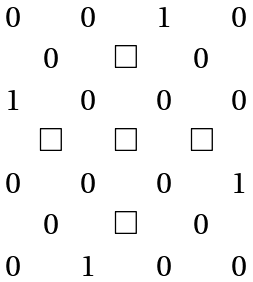Convert formula to latex. <formula><loc_0><loc_0><loc_500><loc_500>\begin{array} { c c c c c c c } 0 & & 0 & & 1 & & 0 \\ & 0 & & \Box & & 0 & \\ 1 & & 0 & & 0 & & 0 \\ & \Box & & \Box & & \Box & \\ 0 & & 0 & & 0 & & 1 \\ & 0 & & \Box & & 0 & \\ 0 & & 1 & & 0 & & 0 \end{array}</formula> 